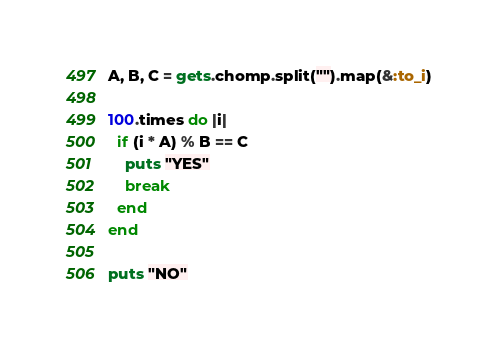Convert code to text. <code><loc_0><loc_0><loc_500><loc_500><_Ruby_>A, B, C = gets.chomp.split("").map(&:to_i)

100.times do |i|
  if (i * A) % B == C
    puts "YES"
    break
  end
end

puts "NO"</code> 